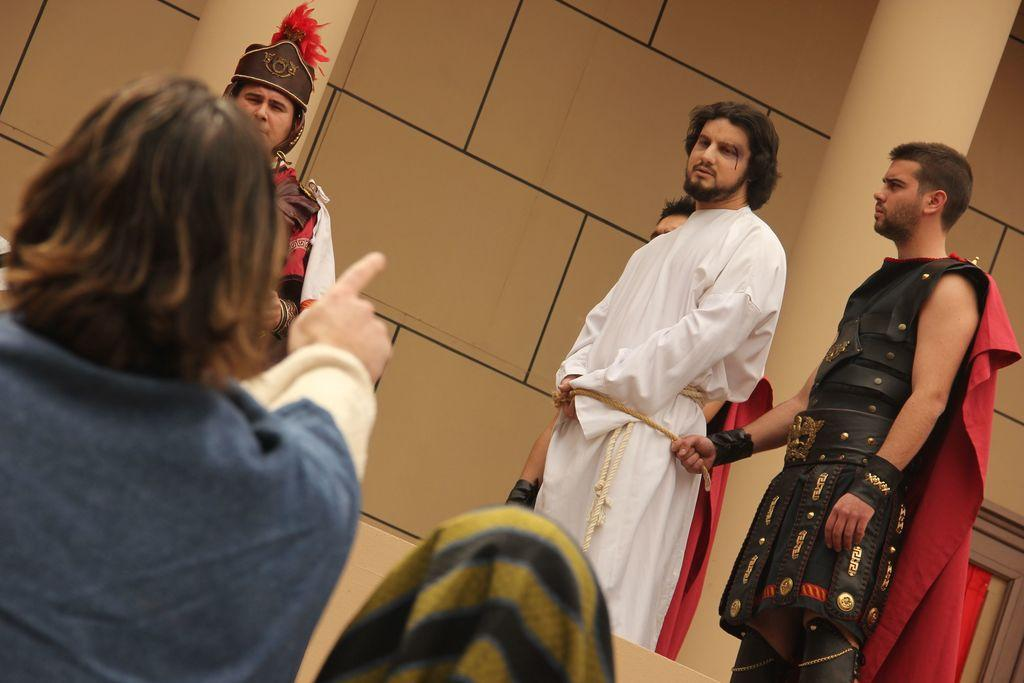How many people are in the foreground of the image? There are two persons in the foreground of the image. What can be seen in the background of the image? There is a building in the background of the image. Are there any other people visible in the image besides the two in the foreground? Yes, there are people standing on the floor in front of the building. What angle can be seen in the image? There is no specific angle mentioned in the image. --- Facts: 1. There is a person in the image. 2. The person is holding a book. 3. The book has a blue cover. 4. The person is sitting on a chair. 5. There is a table next to the chair. Absurd Topics: bird Conversation: How many people are in the image? There is one person in the image. What is the person holding in the image? The person is holding a book. What can be said about the book's cover? The book has a blue cover. What is the person's posture in the image? The person is sitting on a chair. What is located next to the chair? There is a table next to the chair. Reasoning: Let's think step by step in order to produce the conversation. We start by identifying the main subject in the image, which is the person. Next, we describe what the person is holding, which is a book. Then, we provide details about the book, specifically mentioning the color of its cover. After that, we describe the person's posture, which is sitting on a chair. Finally, we mention the presence of a table next to the chair, which adds context to the scene. Absurd Question/Answer: How many birds can be seen in the image? There are no birds visible in the image. 